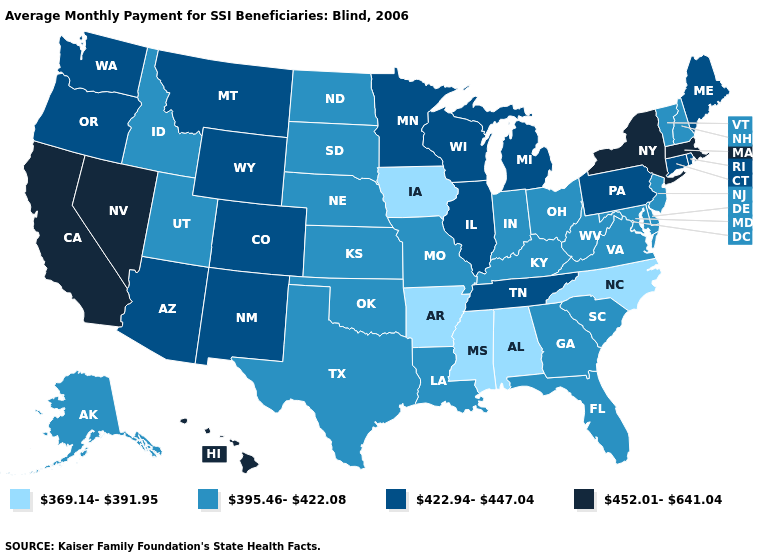Name the states that have a value in the range 452.01-641.04?
Short answer required. California, Hawaii, Massachusetts, Nevada, New York. How many symbols are there in the legend?
Give a very brief answer. 4. Name the states that have a value in the range 369.14-391.95?
Give a very brief answer. Alabama, Arkansas, Iowa, Mississippi, North Carolina. Name the states that have a value in the range 395.46-422.08?
Be succinct. Alaska, Delaware, Florida, Georgia, Idaho, Indiana, Kansas, Kentucky, Louisiana, Maryland, Missouri, Nebraska, New Hampshire, New Jersey, North Dakota, Ohio, Oklahoma, South Carolina, South Dakota, Texas, Utah, Vermont, Virginia, West Virginia. Does the first symbol in the legend represent the smallest category?
Concise answer only. Yes. Name the states that have a value in the range 369.14-391.95?
Answer briefly. Alabama, Arkansas, Iowa, Mississippi, North Carolina. Name the states that have a value in the range 422.94-447.04?
Concise answer only. Arizona, Colorado, Connecticut, Illinois, Maine, Michigan, Minnesota, Montana, New Mexico, Oregon, Pennsylvania, Rhode Island, Tennessee, Washington, Wisconsin, Wyoming. Which states hav the highest value in the Northeast?
Write a very short answer. Massachusetts, New York. Does Georgia have a higher value than Connecticut?
Give a very brief answer. No. Does Oklahoma have the highest value in the USA?
Be succinct. No. Does Washington have a higher value than South Carolina?
Quick response, please. Yes. How many symbols are there in the legend?
Short answer required. 4. Does New Mexico have a lower value than Washington?
Write a very short answer. No. What is the lowest value in states that border Michigan?
Give a very brief answer. 395.46-422.08. Does Iowa have the same value as Hawaii?
Be succinct. No. 